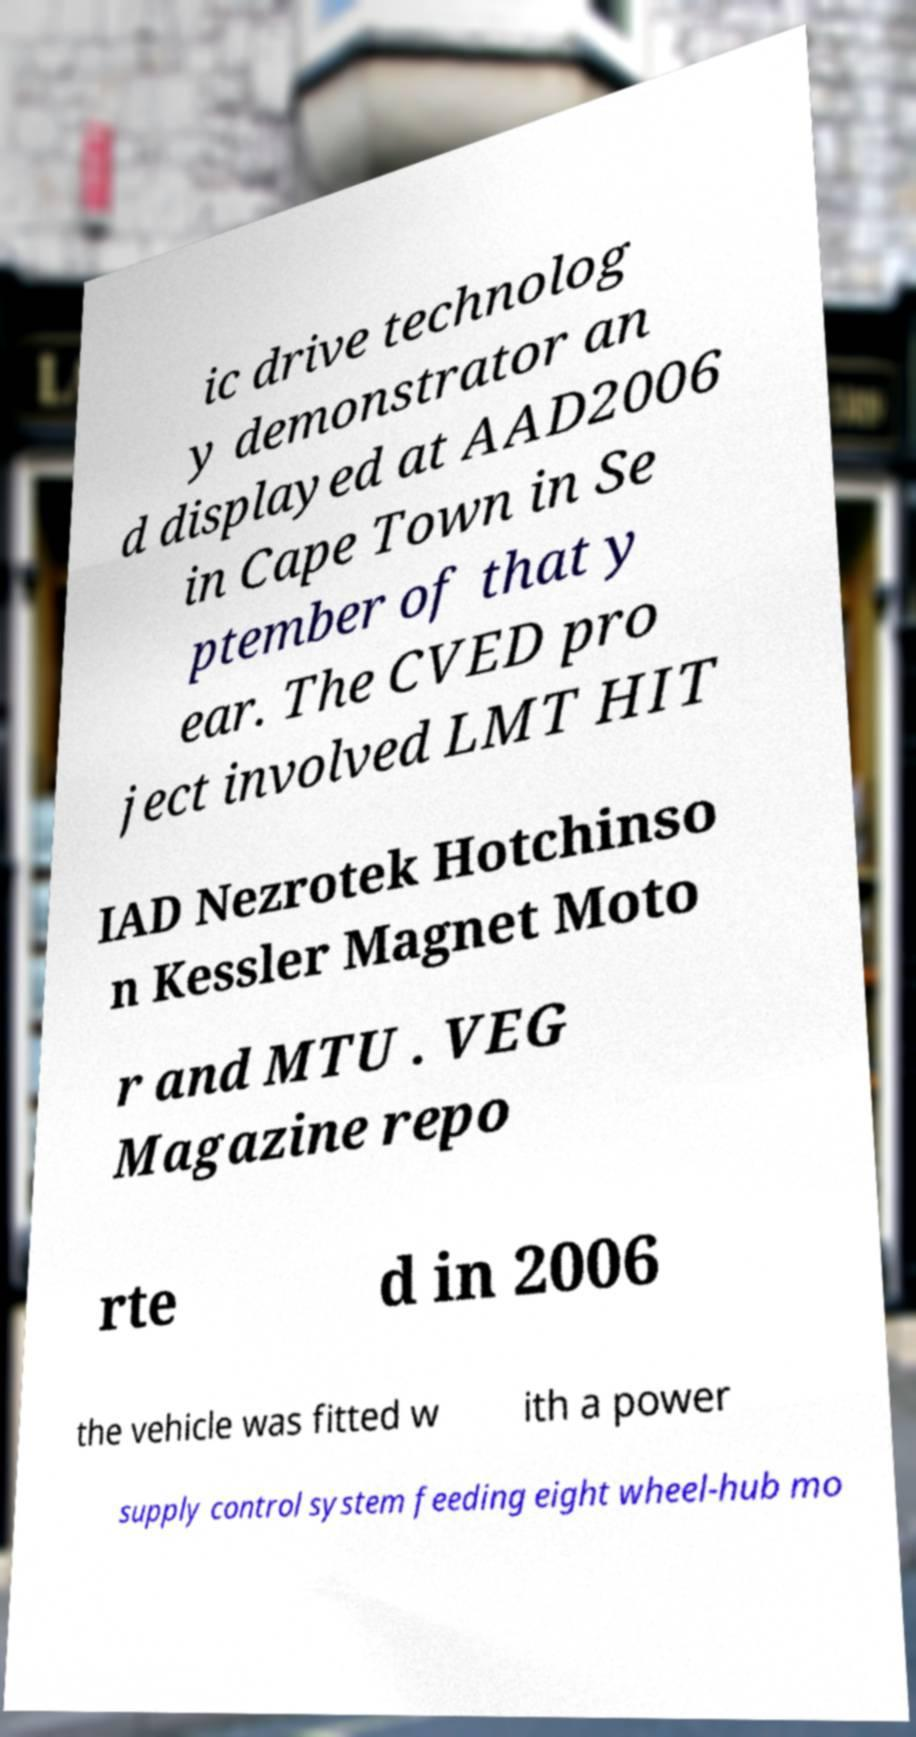Please identify and transcribe the text found in this image. ic drive technolog y demonstrator an d displayed at AAD2006 in Cape Town in Se ptember of that y ear. The CVED pro ject involved LMT HIT IAD Nezrotek Hotchinso n Kessler Magnet Moto r and MTU . VEG Magazine repo rte d in 2006 the vehicle was fitted w ith a power supply control system feeding eight wheel-hub mo 